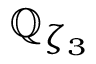<formula> <loc_0><loc_0><loc_500><loc_500>\mathbb { Q } _ { \zeta _ { 3 } }</formula> 